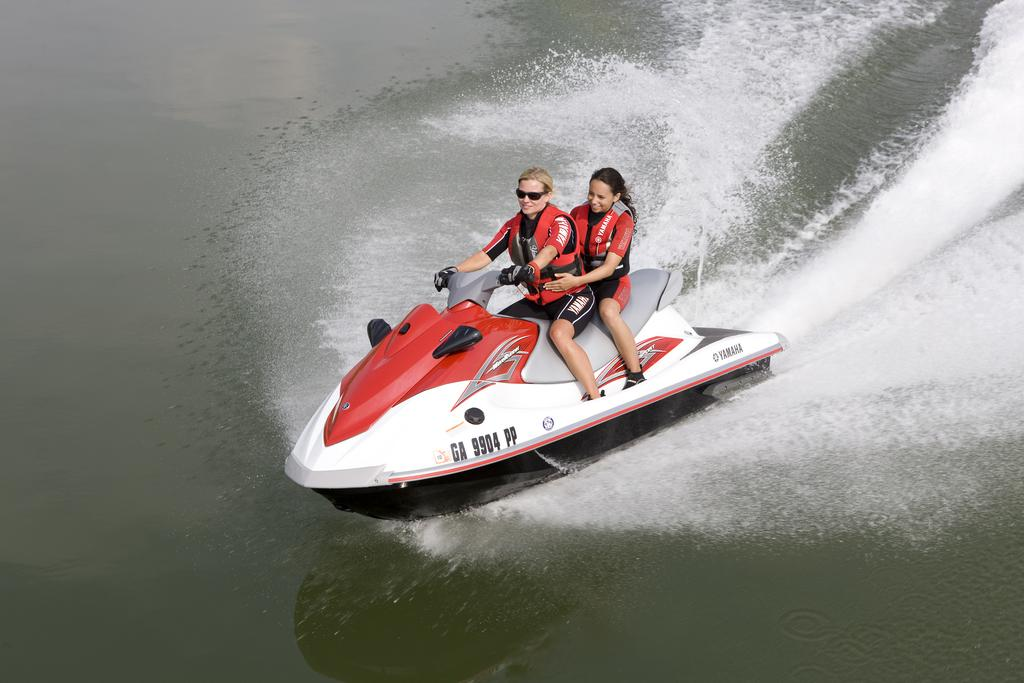What is the main object in the image? There is a Jet Ski in the image. Where is the Jet Ski located? The Jet Ski is on the water. How many people are on the Jet Ski? There are two people on the Jet Ski. What are the people wearing? The people are wearing red color jackets. What position are the people in on the Jet Ski? The people are sitting on the Jet Ski. What is the expression on the people's faces? The people are smiling. What is the name of the club where the Jet Ski is located? There is no information about a club in the image, and the location of the Jet Ski is not specified as being in a club. 